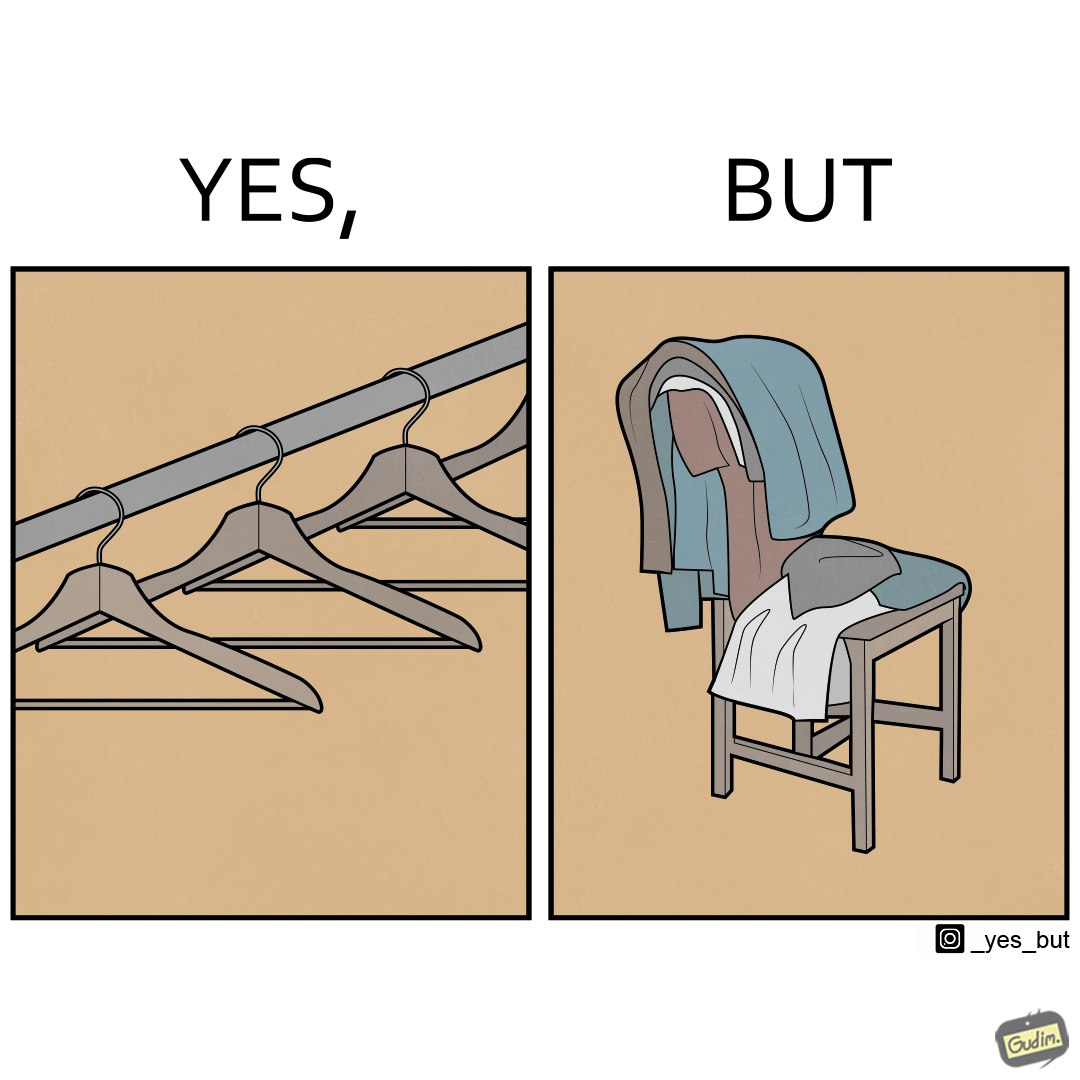What does this image depict? the image highlights irony when people make expensive and fancy wardrobes just to end up stacking all the clothes on a chair 